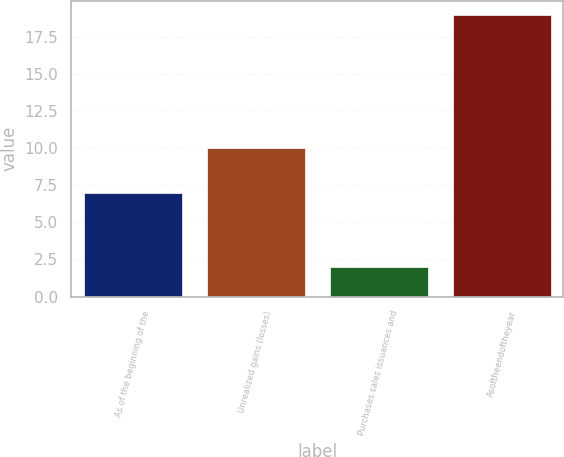<chart> <loc_0><loc_0><loc_500><loc_500><bar_chart><fcel>As of the beginning of the<fcel>Unrealized gains (losses)<fcel>Purchases sales issuances and<fcel>Asoftheendoftheyear<nl><fcel>7<fcel>10<fcel>2<fcel>19<nl></chart> 